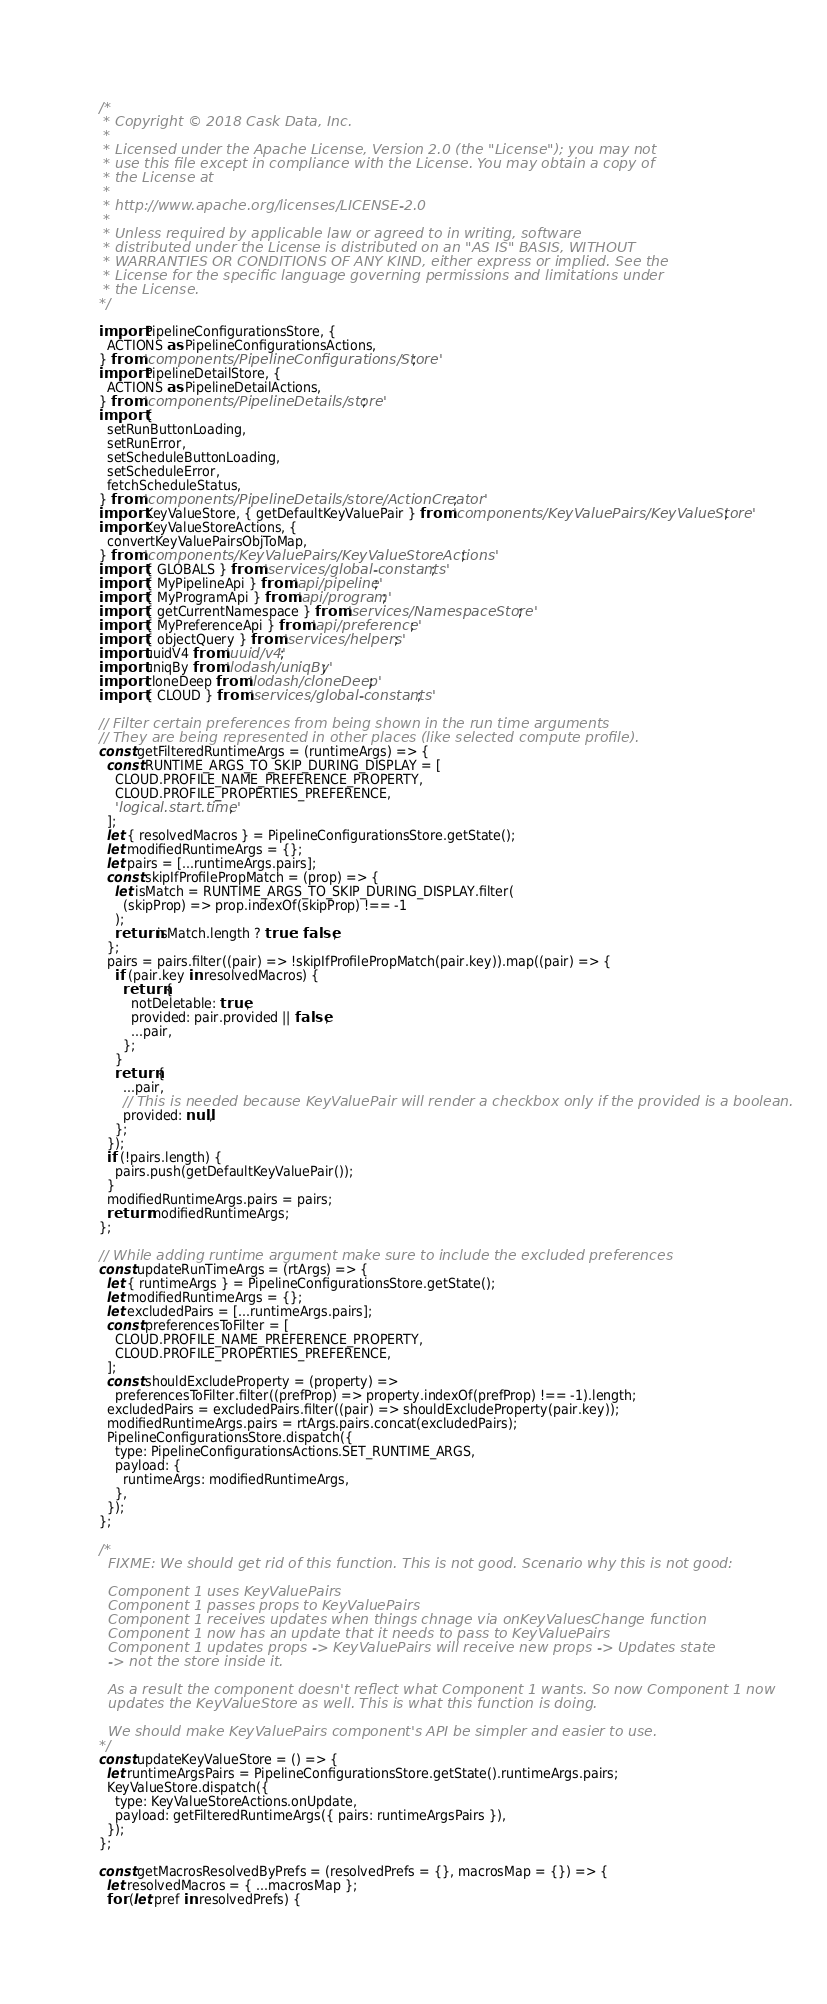Convert code to text. <code><loc_0><loc_0><loc_500><loc_500><_JavaScript_>/*
 * Copyright © 2018 Cask Data, Inc.
 *
 * Licensed under the Apache License, Version 2.0 (the "License"); you may not
 * use this file except in compliance with the License. You may obtain a copy of
 * the License at
 *
 * http://www.apache.org/licenses/LICENSE-2.0
 *
 * Unless required by applicable law or agreed to in writing, software
 * distributed under the License is distributed on an "AS IS" BASIS, WITHOUT
 * WARRANTIES OR CONDITIONS OF ANY KIND, either express or implied. See the
 * License for the specific language governing permissions and limitations under
 * the License.
*/

import PipelineConfigurationsStore, {
  ACTIONS as PipelineConfigurationsActions,
} from 'components/PipelineConfigurations/Store';
import PipelineDetailStore, {
  ACTIONS as PipelineDetailActions,
} from 'components/PipelineDetails/store';
import {
  setRunButtonLoading,
  setRunError,
  setScheduleButtonLoading,
  setScheduleError,
  fetchScheduleStatus,
} from 'components/PipelineDetails/store/ActionCreator';
import KeyValueStore, { getDefaultKeyValuePair } from 'components/KeyValuePairs/KeyValueStore';
import KeyValueStoreActions, {
  convertKeyValuePairsObjToMap,
} from 'components/KeyValuePairs/KeyValueStoreActions';
import { GLOBALS } from 'services/global-constants';
import { MyPipelineApi } from 'api/pipeline';
import { MyProgramApi } from 'api/program';
import { getCurrentNamespace } from 'services/NamespaceStore';
import { MyPreferenceApi } from 'api/preference';
import { objectQuery } from 'services/helpers';
import uuidV4 from 'uuid/v4';
import uniqBy from 'lodash/uniqBy';
import cloneDeep from 'lodash/cloneDeep';
import { CLOUD } from 'services/global-constants';

// Filter certain preferences from being shown in the run time arguments
// They are being represented in other places (like selected compute profile).
const getFilteredRuntimeArgs = (runtimeArgs) => {
  const RUNTIME_ARGS_TO_SKIP_DURING_DISPLAY = [
    CLOUD.PROFILE_NAME_PREFERENCE_PROPERTY,
    CLOUD.PROFILE_PROPERTIES_PREFERENCE,
    'logical.start.time',
  ];
  let { resolvedMacros } = PipelineConfigurationsStore.getState();
  let modifiedRuntimeArgs = {};
  let pairs = [...runtimeArgs.pairs];
  const skipIfProfilePropMatch = (prop) => {
    let isMatch = RUNTIME_ARGS_TO_SKIP_DURING_DISPLAY.filter(
      (skipProp) => prop.indexOf(skipProp) !== -1
    );
    return isMatch.length ? true : false;
  };
  pairs = pairs.filter((pair) => !skipIfProfilePropMatch(pair.key)).map((pair) => {
    if (pair.key in resolvedMacros) {
      return {
        notDeletable: true,
        provided: pair.provided || false,
        ...pair,
      };
    }
    return {
      ...pair,
      // This is needed because KeyValuePair will render a checkbox only if the provided is a boolean.
      provided: null,
    };
  });
  if (!pairs.length) {
    pairs.push(getDefaultKeyValuePair());
  }
  modifiedRuntimeArgs.pairs = pairs;
  return modifiedRuntimeArgs;
};

// While adding runtime argument make sure to include the excluded preferences
const updateRunTimeArgs = (rtArgs) => {
  let { runtimeArgs } = PipelineConfigurationsStore.getState();
  let modifiedRuntimeArgs = {};
  let excludedPairs = [...runtimeArgs.pairs];
  const preferencesToFilter = [
    CLOUD.PROFILE_NAME_PREFERENCE_PROPERTY,
    CLOUD.PROFILE_PROPERTIES_PREFERENCE,
  ];
  const shouldExcludeProperty = (property) =>
    preferencesToFilter.filter((prefProp) => property.indexOf(prefProp) !== -1).length;
  excludedPairs = excludedPairs.filter((pair) => shouldExcludeProperty(pair.key));
  modifiedRuntimeArgs.pairs = rtArgs.pairs.concat(excludedPairs);
  PipelineConfigurationsStore.dispatch({
    type: PipelineConfigurationsActions.SET_RUNTIME_ARGS,
    payload: {
      runtimeArgs: modifiedRuntimeArgs,
    },
  });
};

/*
  FIXME: We should get rid of this function. This is not good. Scenario why this is not good:

  Component 1 uses KeyValuePairs
  Component 1 passes props to KeyValuePairs
  Component 1 receives updates when things chnage via onKeyValuesChange function
  Component 1 now has an update that it needs to pass to KeyValuePairs
  Component 1 updates props -> KeyValuePairs will receive new props -> Updates state
  -> not the store inside it.

  As a result the component doesn't reflect what Component 1 wants. So now Component 1 now
  updates the KeyValueStore as well. This is what this function is doing.

  We should make KeyValuePairs component's API be simpler and easier to use.
*/
const updateKeyValueStore = () => {
  let runtimeArgsPairs = PipelineConfigurationsStore.getState().runtimeArgs.pairs;
  KeyValueStore.dispatch({
    type: KeyValueStoreActions.onUpdate,
    payload: getFilteredRuntimeArgs({ pairs: runtimeArgsPairs }),
  });
};

const getMacrosResolvedByPrefs = (resolvedPrefs = {}, macrosMap = {}) => {
  let resolvedMacros = { ...macrosMap };
  for (let pref in resolvedPrefs) {</code> 